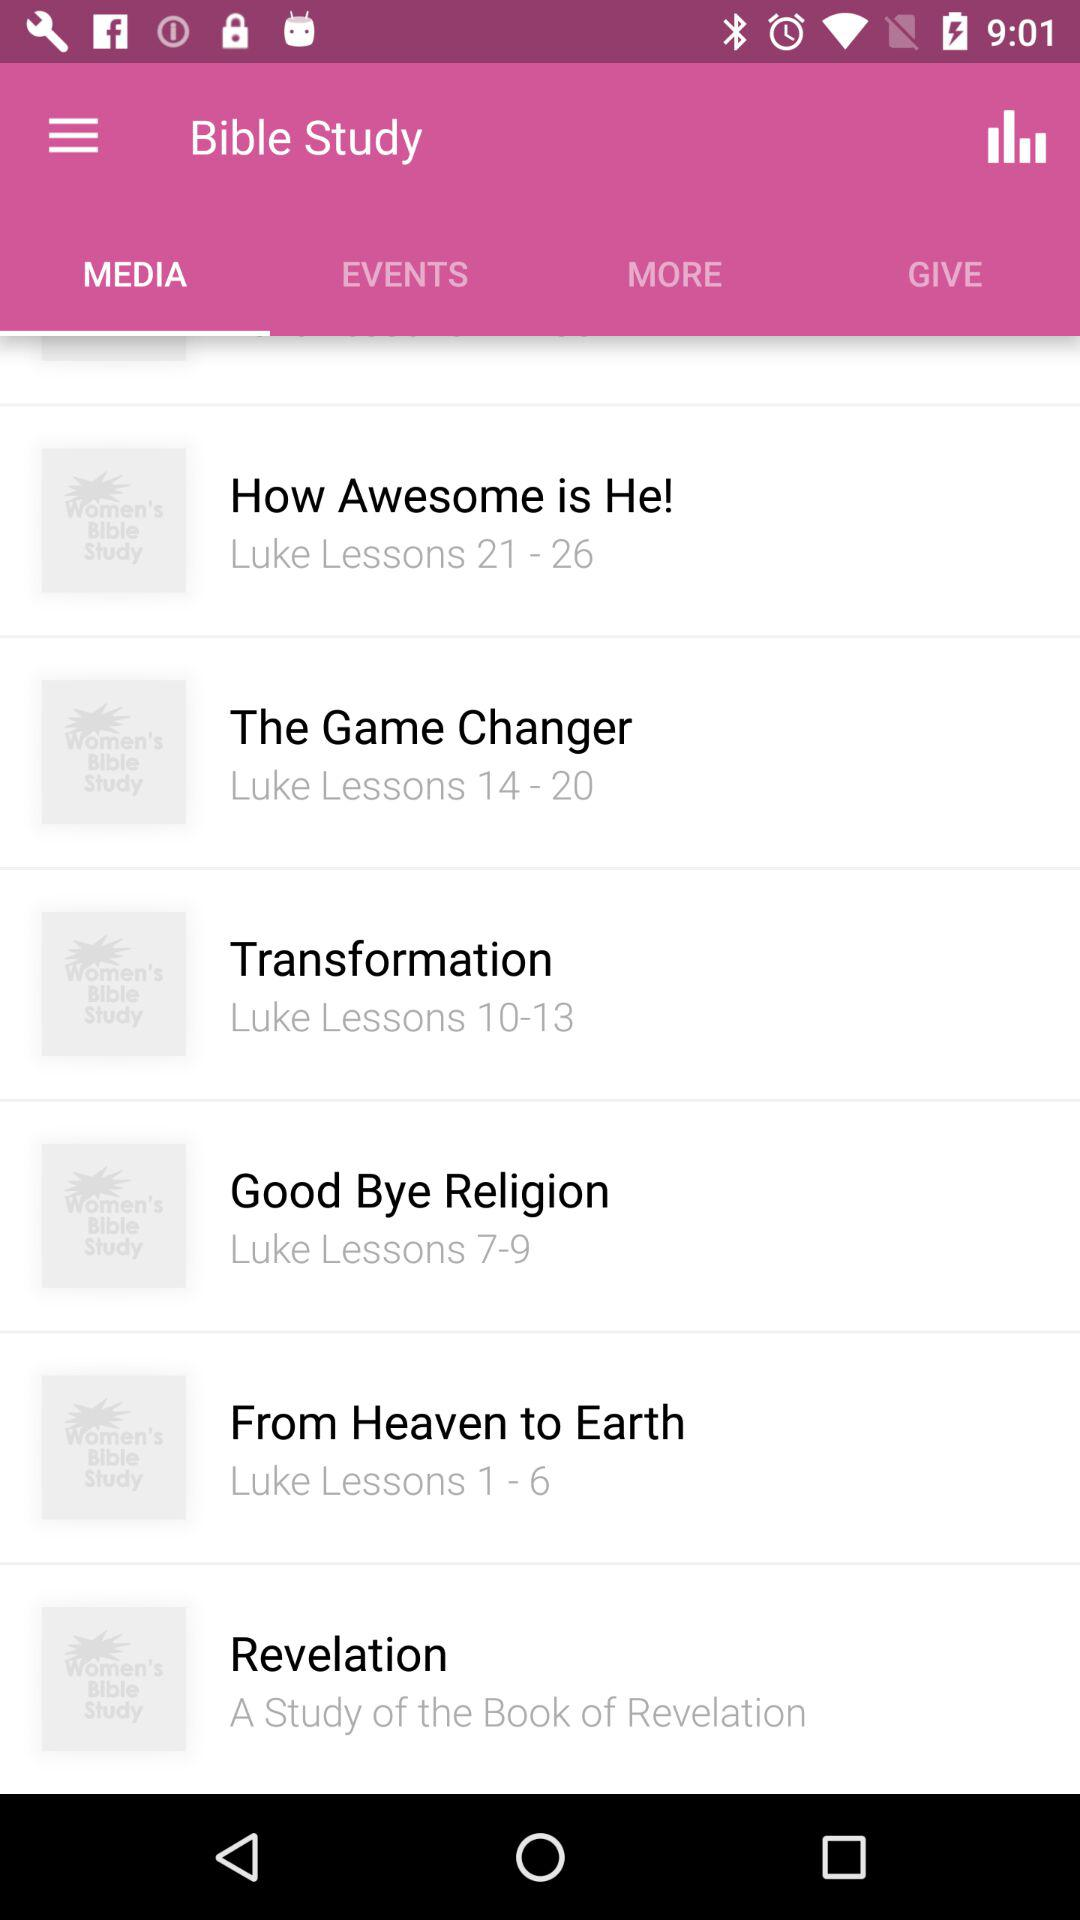Which option is selected in "Bible Study"? The selected option is "MEDIA". 